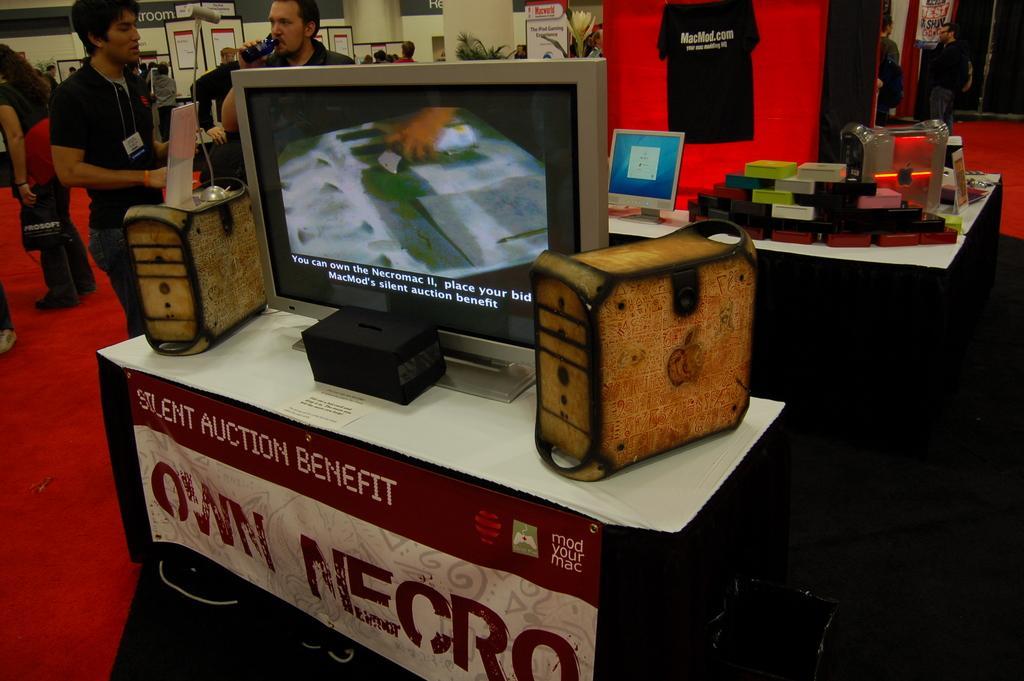Can you describe this image briefly? In this image there are tables, there are objects on the table, there are monitors, there are boards, there is text on the boards, there are group of persons standing, the persons are holding an object, there are pillars towards the top of the image, there are plants, there is a red carpet towards the left of the image. 